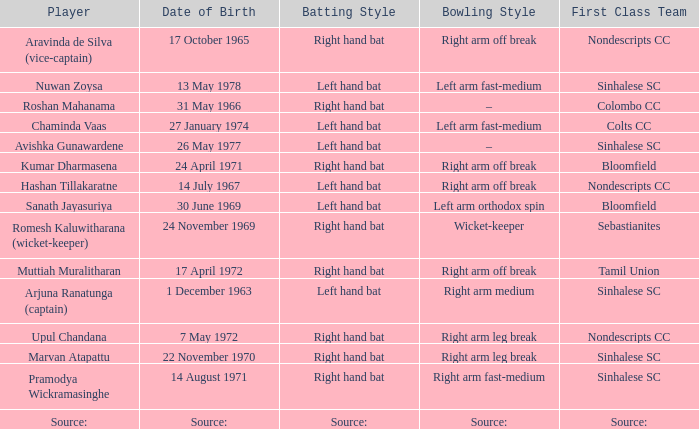Who has a bowling style of source:? Source:. 